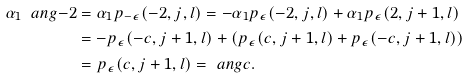Convert formula to latex. <formula><loc_0><loc_0><loc_500><loc_500>\alpha _ { 1 } \ a n g { - 2 } & = \alpha _ { 1 } p _ { - \epsilon } ( - 2 , j , l ) = - \alpha _ { 1 } p _ { \epsilon } ( - 2 , j , l ) + \alpha _ { 1 } p _ { \epsilon } ( 2 , j + 1 , l ) \\ & = - p _ { \epsilon } ( - c , j + 1 , l ) + ( p _ { \epsilon } ( c , j + 1 , l ) + p _ { \epsilon } ( - c , j + 1 , l ) ) \\ & = p _ { \epsilon } ( c , j + 1 , l ) = \ a n g { c } .</formula> 